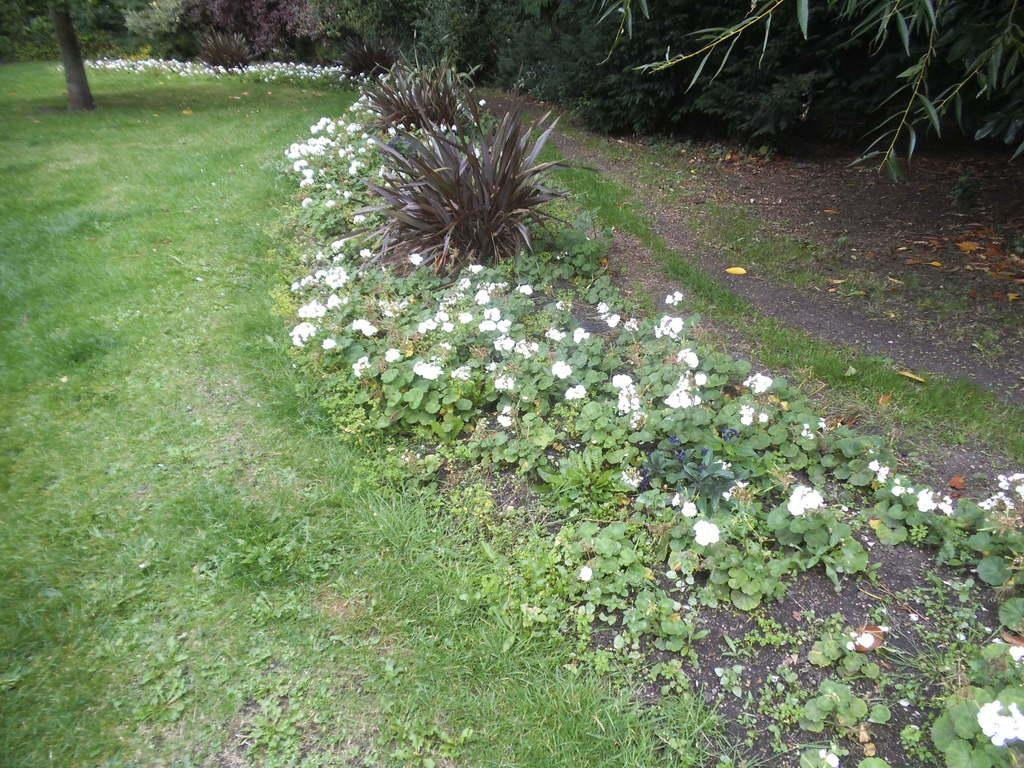What types of plants can be seen in the foreground of the image? There are flowers and plants in the foreground of the image. What type of ground cover is present in the foreground of the image? There is grass in the foreground of the image. What is visible at the top of the image? There is a trunk, flowers, and greenery visible at the top of the image. How many fingers can be seen holding the flowers in the image? There are no fingers or people holding flowers in the image; it only shows plants and flowers. What type of glue is used to attach the birds to the trunk in the image? There are no birds or glue present in the image; it only shows a trunk, flowers, and greenery. 